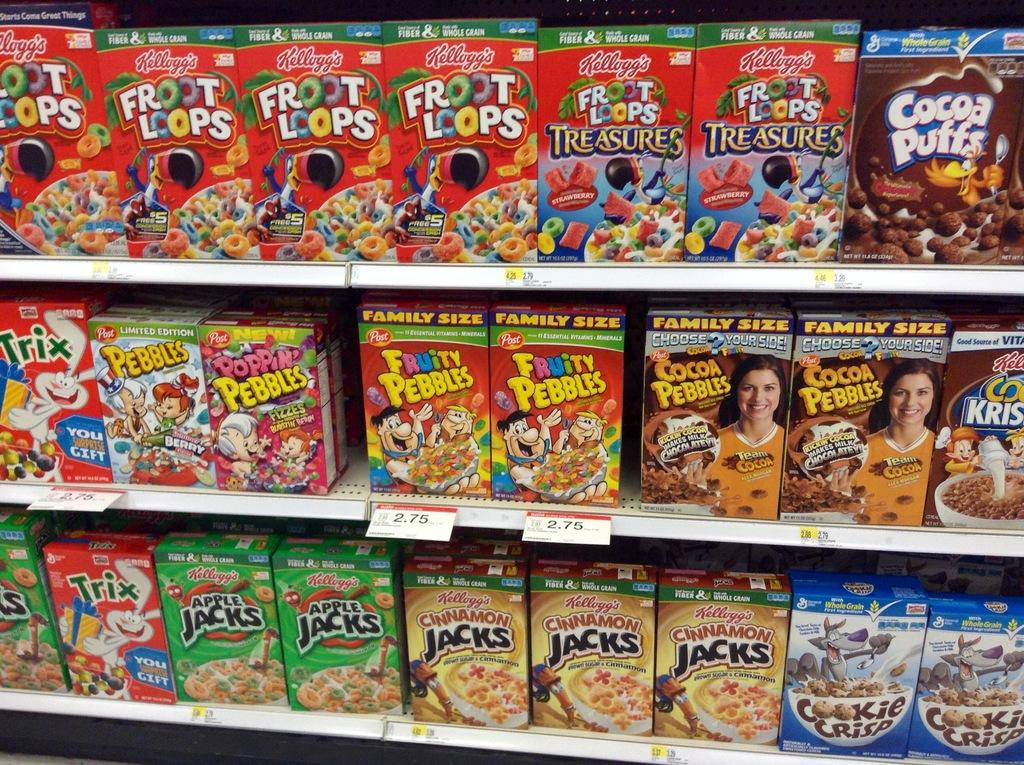<image>
Give a short and clear explanation of the subsequent image. a box of fruity pebbles that are on a store shelf 